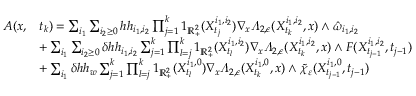<formula> <loc_0><loc_0><loc_500><loc_500>\begin{array} { r l } { A ( x , } & { t _ { k } ) = \sum _ { i _ { 1 } } \sum _ { i _ { 2 } \geq 0 } h h _ { i _ { 1 } , i _ { 2 } } \prod _ { j = 1 } ^ { k } 1 _ { \mathbb { R } _ { + } ^ { 2 } } ( X _ { t _ { j } } ^ { i _ { 1 } , i _ { 2 } } ) \nabla _ { x } \varLambda _ { 2 , \epsilon } ( X _ { t _ { k } } ^ { i _ { 1 } , i _ { 2 } } , x ) \wedge \hat { \omega } _ { i _ { 1 } , i _ { 2 } } } \\ & { + \sum _ { i _ { 1 } } \sum _ { i _ { 2 } \geq 0 } \delta h h _ { i _ { 1 } , i _ { 2 } } \sum _ { j = 1 } ^ { k } \prod _ { l = j } ^ { k } 1 _ { \mathbb { R } _ { + } ^ { 2 } } ( X _ { t _ { l } } ^ { i _ { 1 } , i _ { 2 } } ) \nabla _ { x } \varLambda _ { 2 , \epsilon } ( X _ { t _ { k } } ^ { i _ { 1 } , i _ { 2 } } , x ) \wedge F ( X _ { t _ { j - 1 } } ^ { i _ { 1 } , i _ { 2 } } , t _ { j - 1 } ) } \\ & { + \sum _ { i _ { 1 } } \delta h h _ { w } \sum _ { j = 1 } ^ { k } \prod _ { l = j } ^ { k } 1 _ { \mathbb { R } _ { + } ^ { 2 } } ( X _ { t _ { l } } ^ { i _ { 1 } , 0 } ) \nabla _ { x } \varLambda _ { 2 , \epsilon } ( X _ { t _ { k } } ^ { i _ { 1 } , 0 } , x ) \wedge \tilde { \chi } _ { \varepsilon } ( X _ { t _ { j - 1 } } ^ { i _ { 1 } , 0 } , t _ { j - 1 } ) } \end{array}</formula> 